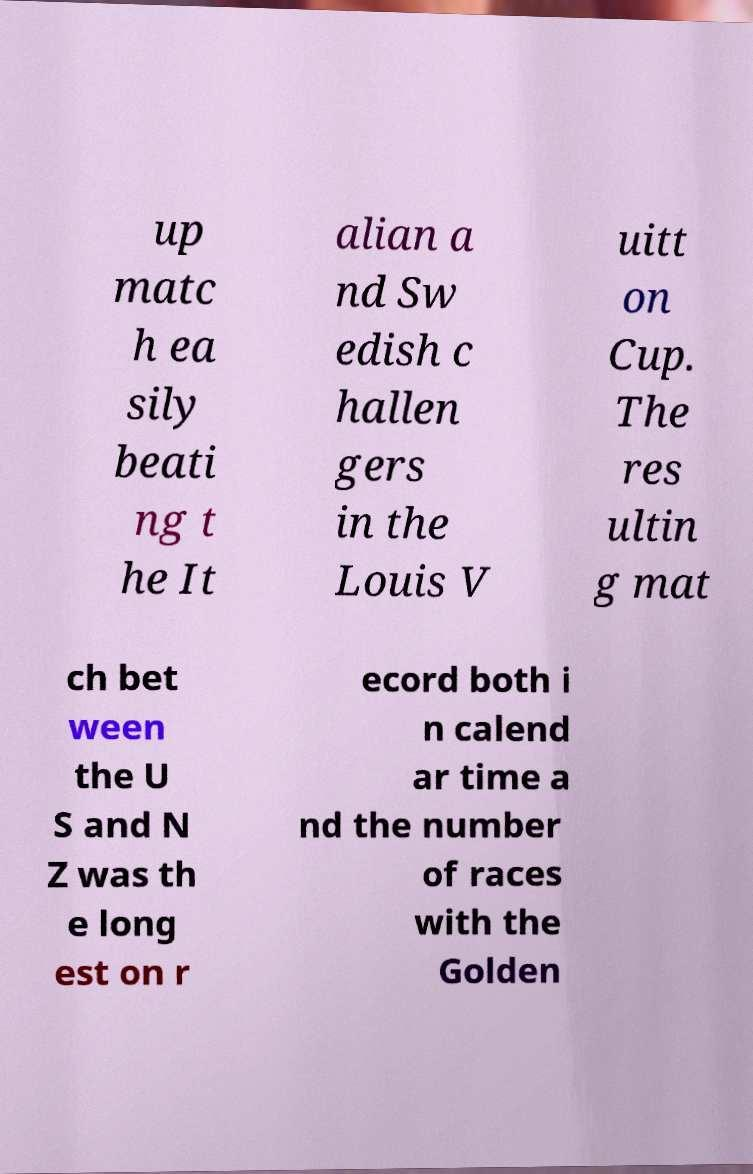Could you assist in decoding the text presented in this image and type it out clearly? up matc h ea sily beati ng t he It alian a nd Sw edish c hallen gers in the Louis V uitt on Cup. The res ultin g mat ch bet ween the U S and N Z was th e long est on r ecord both i n calend ar time a nd the number of races with the Golden 